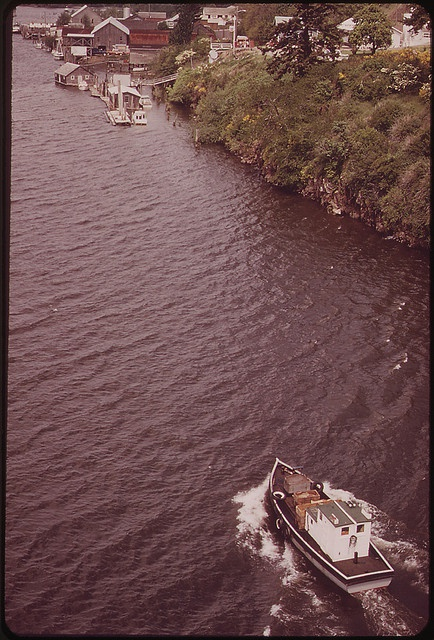Describe the objects in this image and their specific colors. I can see boat in black, maroon, brown, and darkgray tones, boat in black, darkgray, brown, and maroon tones, boat in black, lightgray, and darkgray tones, boat in black, darkgray, brown, and lightgray tones, and boat in black, darkgray, maroon, brown, and pink tones in this image. 